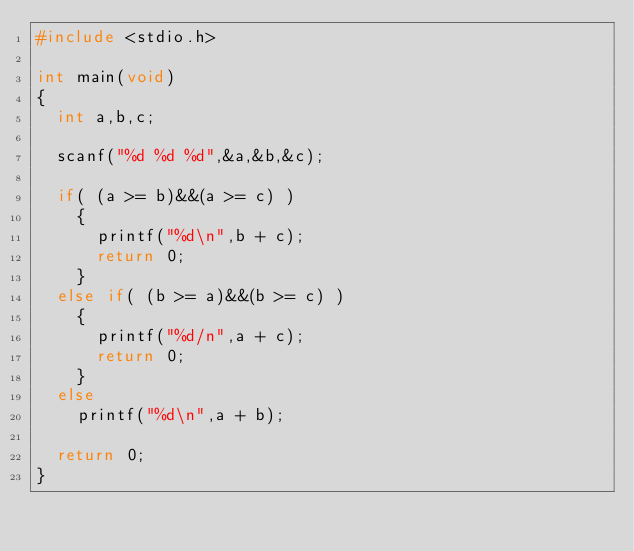Convert code to text. <code><loc_0><loc_0><loc_500><loc_500><_C_>#include <stdio.h>

int main(void)
{
  int a,b,c;

  scanf("%d %d %d",&a,&b,&c);

  if( (a >= b)&&(a >= c) )
    {
      printf("%d\n",b + c);
      return 0;
    }
  else if( (b >= a)&&(b >= c) )
    {
      printf("%d/n",a + c);
      return 0;
    }
  else
    printf("%d\n",a + b);

  return 0;
}






</code> 